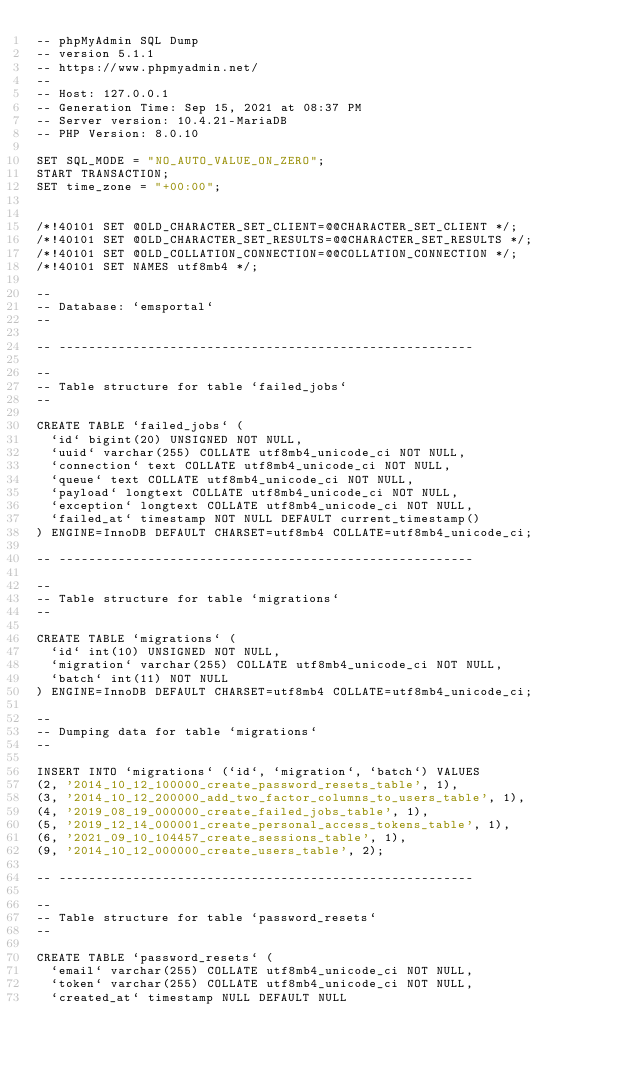<code> <loc_0><loc_0><loc_500><loc_500><_SQL_>-- phpMyAdmin SQL Dump
-- version 5.1.1
-- https://www.phpmyadmin.net/
--
-- Host: 127.0.0.1
-- Generation Time: Sep 15, 2021 at 08:37 PM
-- Server version: 10.4.21-MariaDB
-- PHP Version: 8.0.10

SET SQL_MODE = "NO_AUTO_VALUE_ON_ZERO";
START TRANSACTION;
SET time_zone = "+00:00";


/*!40101 SET @OLD_CHARACTER_SET_CLIENT=@@CHARACTER_SET_CLIENT */;
/*!40101 SET @OLD_CHARACTER_SET_RESULTS=@@CHARACTER_SET_RESULTS */;
/*!40101 SET @OLD_COLLATION_CONNECTION=@@COLLATION_CONNECTION */;
/*!40101 SET NAMES utf8mb4 */;

--
-- Database: `emsportal`
--

-- --------------------------------------------------------

--
-- Table structure for table `failed_jobs`
--

CREATE TABLE `failed_jobs` (
  `id` bigint(20) UNSIGNED NOT NULL,
  `uuid` varchar(255) COLLATE utf8mb4_unicode_ci NOT NULL,
  `connection` text COLLATE utf8mb4_unicode_ci NOT NULL,
  `queue` text COLLATE utf8mb4_unicode_ci NOT NULL,
  `payload` longtext COLLATE utf8mb4_unicode_ci NOT NULL,
  `exception` longtext COLLATE utf8mb4_unicode_ci NOT NULL,
  `failed_at` timestamp NOT NULL DEFAULT current_timestamp()
) ENGINE=InnoDB DEFAULT CHARSET=utf8mb4 COLLATE=utf8mb4_unicode_ci;

-- --------------------------------------------------------

--
-- Table structure for table `migrations`
--

CREATE TABLE `migrations` (
  `id` int(10) UNSIGNED NOT NULL,
  `migration` varchar(255) COLLATE utf8mb4_unicode_ci NOT NULL,
  `batch` int(11) NOT NULL
) ENGINE=InnoDB DEFAULT CHARSET=utf8mb4 COLLATE=utf8mb4_unicode_ci;

--
-- Dumping data for table `migrations`
--

INSERT INTO `migrations` (`id`, `migration`, `batch`) VALUES
(2, '2014_10_12_100000_create_password_resets_table', 1),
(3, '2014_10_12_200000_add_two_factor_columns_to_users_table', 1),
(4, '2019_08_19_000000_create_failed_jobs_table', 1),
(5, '2019_12_14_000001_create_personal_access_tokens_table', 1),
(6, '2021_09_10_104457_create_sessions_table', 1),
(9, '2014_10_12_000000_create_users_table', 2);

-- --------------------------------------------------------

--
-- Table structure for table `password_resets`
--

CREATE TABLE `password_resets` (
  `email` varchar(255) COLLATE utf8mb4_unicode_ci NOT NULL,
  `token` varchar(255) COLLATE utf8mb4_unicode_ci NOT NULL,
  `created_at` timestamp NULL DEFAULT NULL</code> 